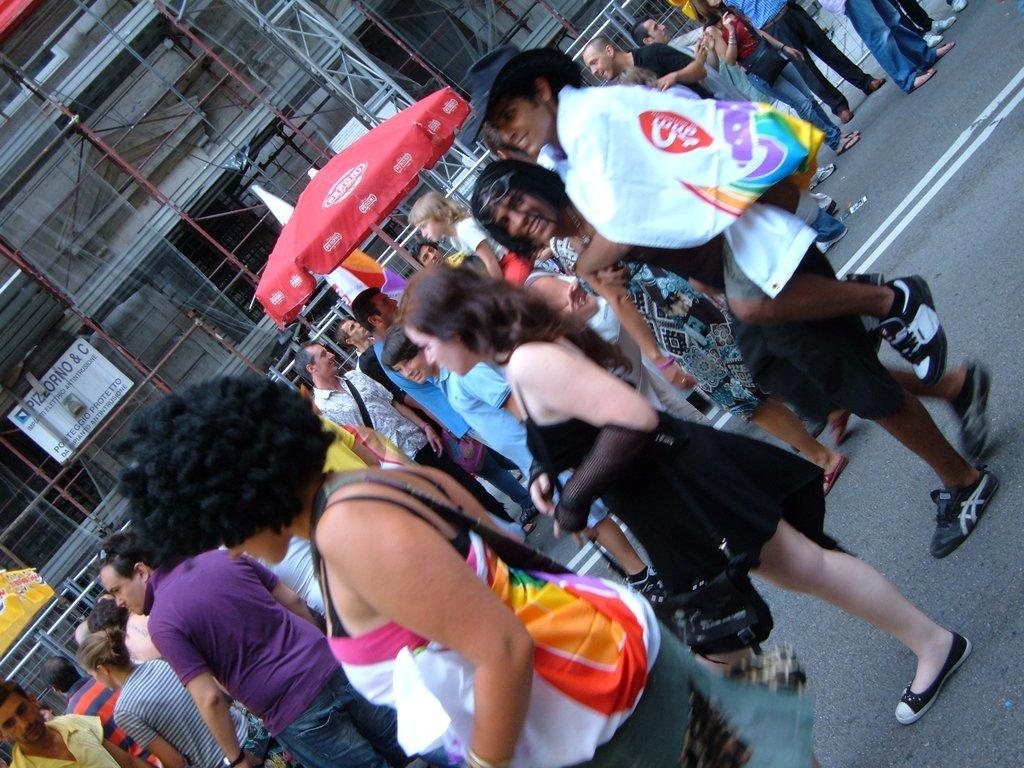What is the main subject in the center of the image? There is a group of people in the center of the image. What type of shelter can be seen in the image? There is a tent present in the image. What structure is located at the top of the image? There is a building at the top of the image. What are the rods and board at the top of the image used for? The rods and board at the top of the image are likely used for supporting or displaying something. What is visible on the right side of the image? There is a road on the right side of the image. What month is it in the image? The month cannot be determined from the image, as there are no indications of time or season. Who is the creator of the image? The creator of the image cannot be determined from the image itself, as it does not contain any information about the artist or photographer. 